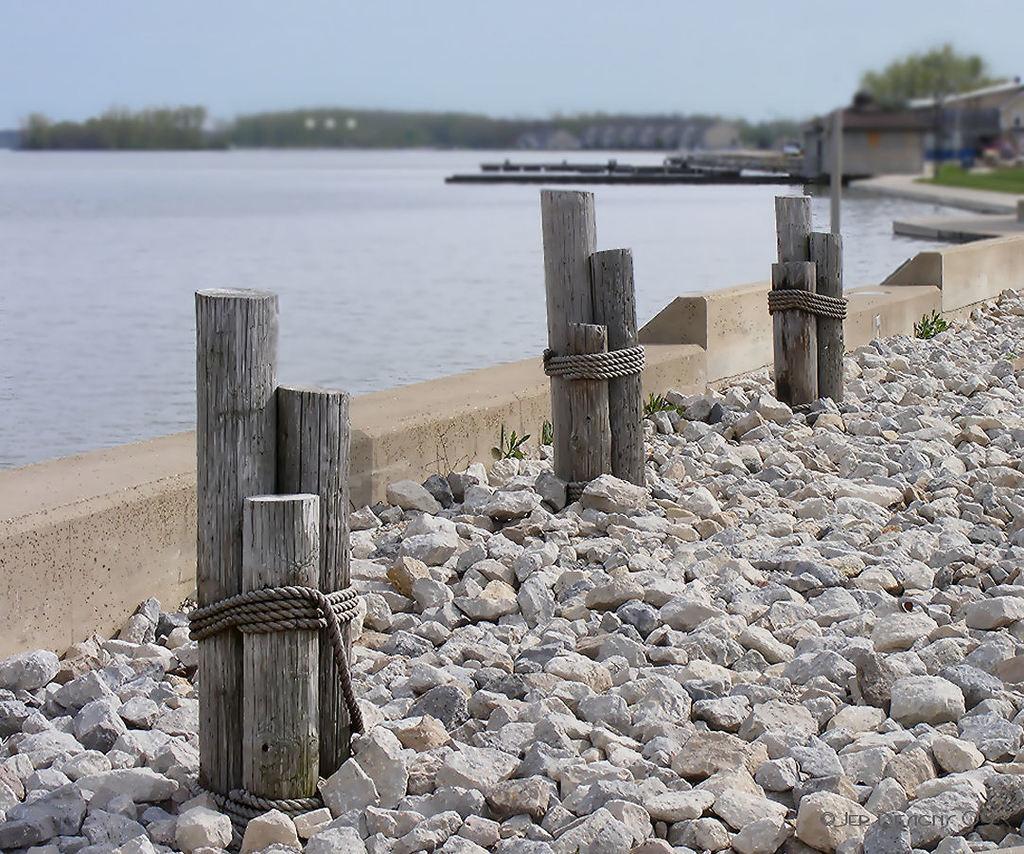Can you describe this image briefly? In this image in front there are rocks. There are wooden logs tied with ropes. In the center of the image there is water. In the background of the image there are buildings, trees and sky. There is some text at the bottom of the image. 